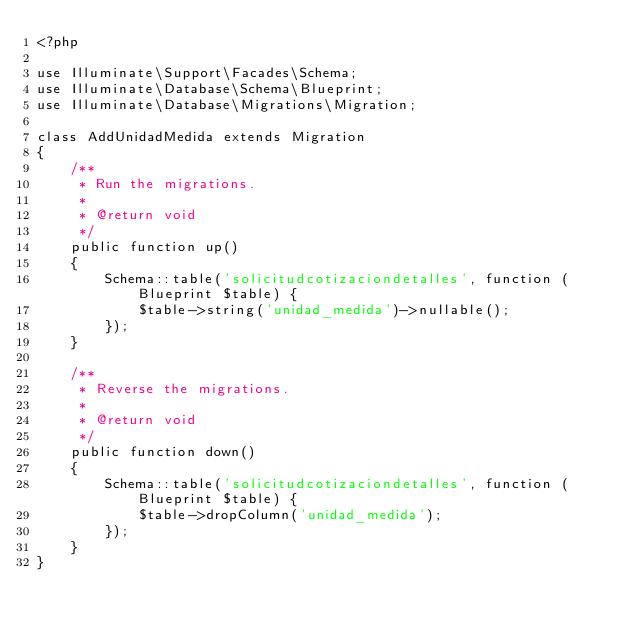Convert code to text. <code><loc_0><loc_0><loc_500><loc_500><_PHP_><?php

use Illuminate\Support\Facades\Schema;
use Illuminate\Database\Schema\Blueprint;
use Illuminate\Database\Migrations\Migration;

class AddUnidadMedida extends Migration
{
    /**
     * Run the migrations.
     *
     * @return void
     */
    public function up()
    {
        Schema::table('solicitudcotizaciondetalles', function (Blueprint $table) {
            $table->string('unidad_medida')->nullable();
        });
    }

    /**
     * Reverse the migrations.
     *
     * @return void
     */
    public function down()
    {
        Schema::table('solicitudcotizaciondetalles', function (Blueprint $table) {
            $table->dropColumn('unidad_medida');
        });
    }
}
</code> 